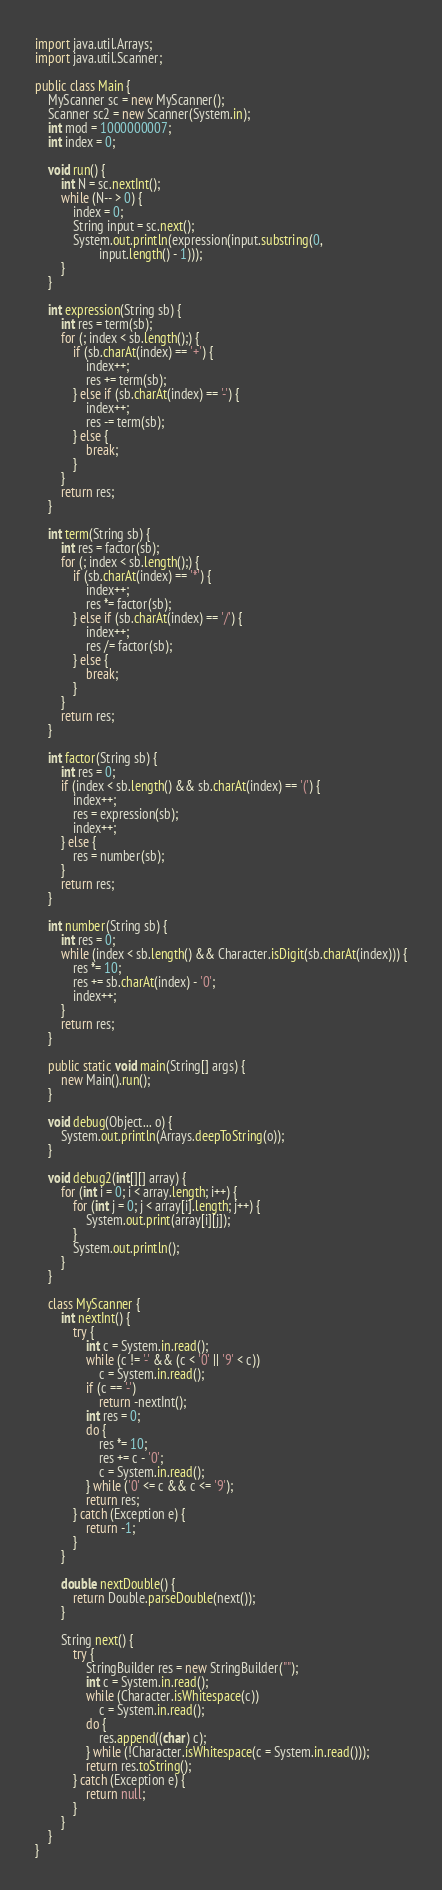Convert code to text. <code><loc_0><loc_0><loc_500><loc_500><_Java_>import java.util.Arrays;
import java.util.Scanner;

public class Main {
	MyScanner sc = new MyScanner();
	Scanner sc2 = new Scanner(System.in);
	int mod = 1000000007;
	int index = 0;

	void run() {
		int N = sc.nextInt();
		while (N-- > 0) {
			index = 0;
			String input = sc.next();
			System.out.println(expression(input.substring(0,
					input.length() - 1)));
		}
	}

	int expression(String sb) {
		int res = term(sb);
		for (; index < sb.length();) {
			if (sb.charAt(index) == '+') {
				index++;
				res += term(sb);
			} else if (sb.charAt(index) == '-') {
				index++;
				res -= term(sb);
			} else {
				break;
			}
		}
		return res;
	}

	int term(String sb) {
		int res = factor(sb);
		for (; index < sb.length();) {
			if (sb.charAt(index) == '*') {
				index++;
				res *= factor(sb);
			} else if (sb.charAt(index) == '/') {
				index++;
				res /= factor(sb);
			} else {
				break;
			}
		}
		return res;
	}

	int factor(String sb) {
		int res = 0;
		if (index < sb.length() && sb.charAt(index) == '(') {
			index++;
			res = expression(sb);
			index++;
		} else {
			res = number(sb);
		}
		return res;
	}

	int number(String sb) {
		int res = 0;
		while (index < sb.length() && Character.isDigit(sb.charAt(index))) {
			res *= 10;
			res += sb.charAt(index) - '0';
			index++;
		}
		return res;
	}

	public static void main(String[] args) {
		new Main().run();
	}

	void debug(Object... o) {
		System.out.println(Arrays.deepToString(o));
	}

	void debug2(int[][] array) {
		for (int i = 0; i < array.length; i++) {
			for (int j = 0; j < array[i].length; j++) {
				System.out.print(array[i][j]);
			}
			System.out.println();
		}
	}

	class MyScanner {
		int nextInt() {
			try {
				int c = System.in.read();
				while (c != '-' && (c < '0' || '9' < c))
					c = System.in.read();
				if (c == '-')
					return -nextInt();
				int res = 0;
				do {
					res *= 10;
					res += c - '0';
					c = System.in.read();
				} while ('0' <= c && c <= '9');
				return res;
			} catch (Exception e) {
				return -1;
			}
		}

		double nextDouble() {
			return Double.parseDouble(next());
		}

		String next() {
			try {
				StringBuilder res = new StringBuilder("");
				int c = System.in.read();
				while (Character.isWhitespace(c))
					c = System.in.read();
				do {
					res.append((char) c);
				} while (!Character.isWhitespace(c = System.in.read()));
				return res.toString();
			} catch (Exception e) {
				return null;
			}
		}
	}
}</code> 